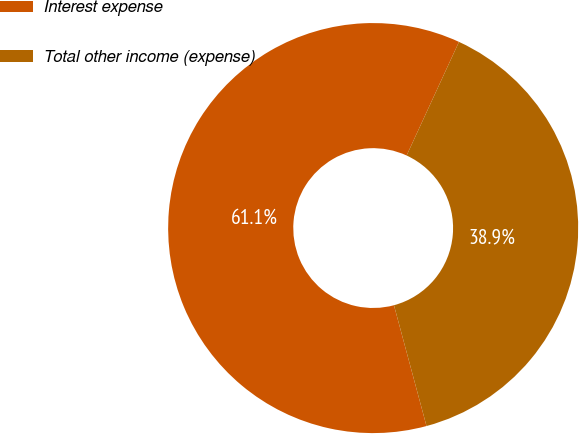<chart> <loc_0><loc_0><loc_500><loc_500><pie_chart><fcel>Interest expense<fcel>Total other income (expense)<nl><fcel>61.06%<fcel>38.94%<nl></chart> 